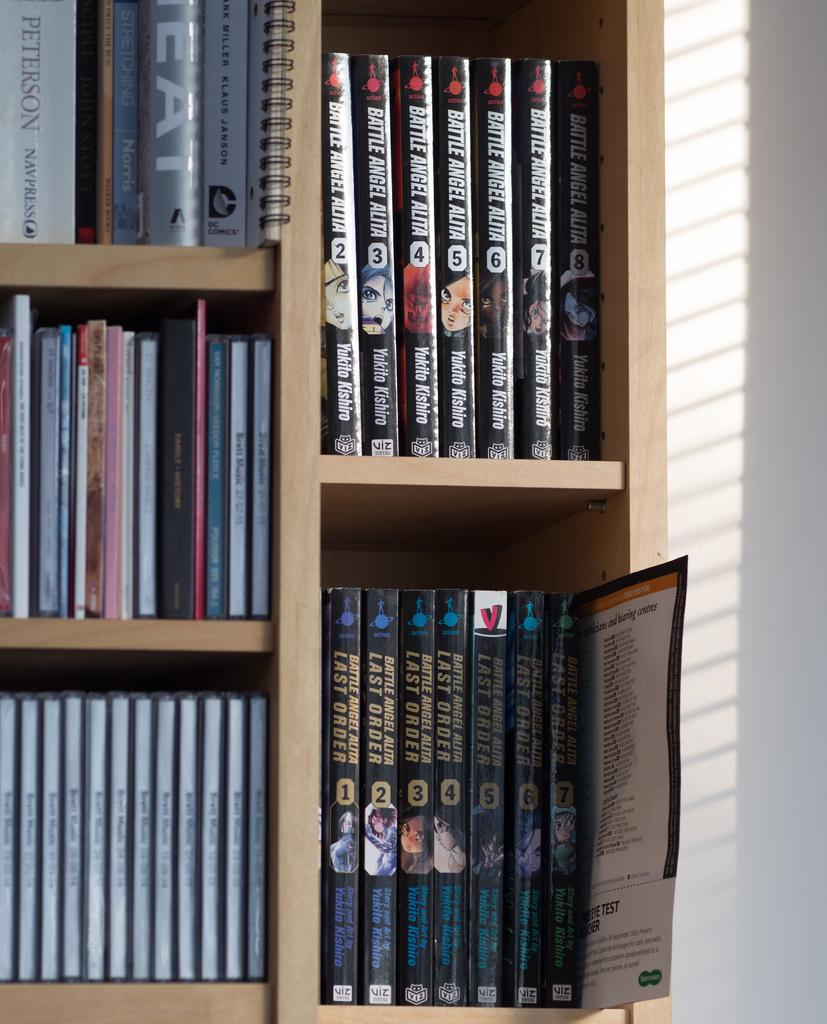Provide a one-sentence caption for the provided image. A book shelf that has various titles including  a manga book series called battle angel alita. 